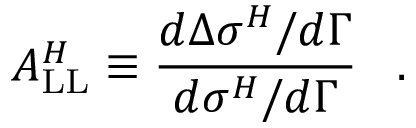Convert formula to latex. <formula><loc_0><loc_0><loc_500><loc_500>A _ { L L } ^ { H } \equiv \frac { d \Delta \sigma ^ { H } / d \Gamma } { d \sigma ^ { H } / d \Gamma } \, .</formula> 